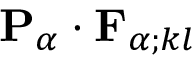<formula> <loc_0><loc_0><loc_500><loc_500>{ P } _ { \alpha } \cdot { F } _ { \alpha ; k l }</formula> 